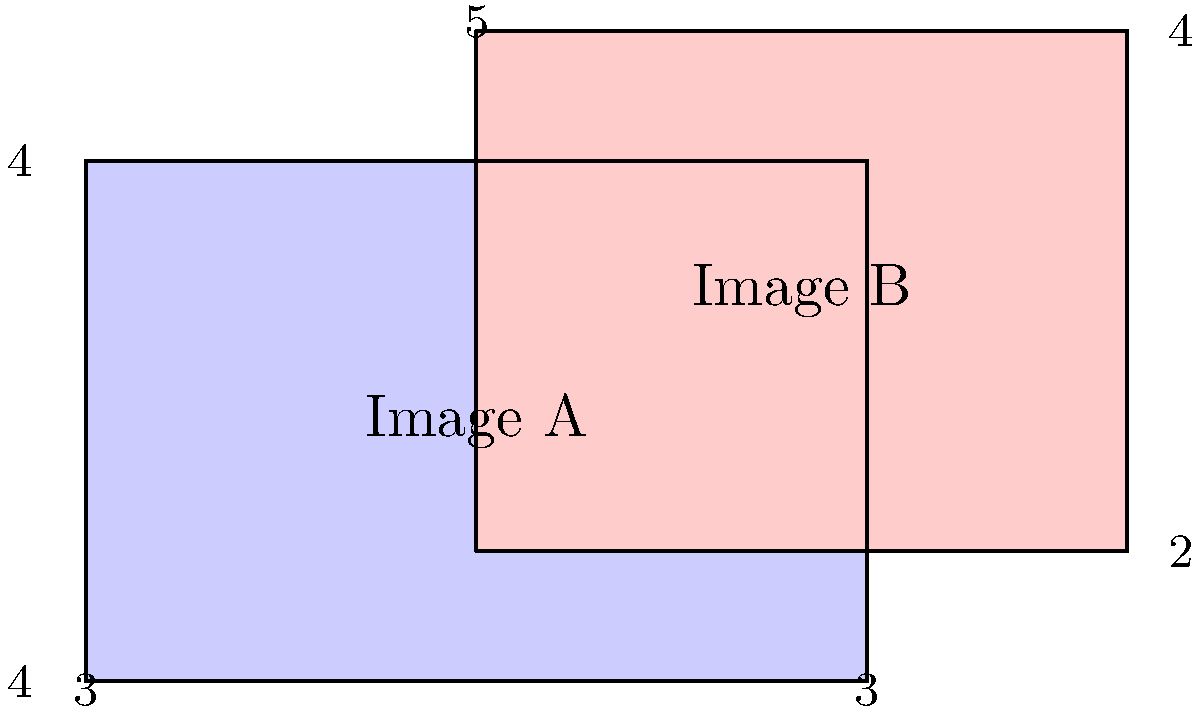You're working on an iOS app that processes PNG images. You need to calculate the difference in area between two overlapping image masks, represented by rectangles A and B in the diagram. The dimensions are given in arbitrary units. What is the difference in area between the non-overlapping regions of these two masks? To solve this problem, we'll follow these steps:

1. Calculate the area of Image A:
   $A_A = 6 * 4 = 24$ square units

2. Calculate the area of Image B:
   $A_B = 5 * 4 = 20$ square units

3. Calculate the area of the overlapping region:
   Width of overlap = $6 - 3 = 3$ units
   Height of overlap = $4 - 1 = 3$ units
   $A_{overlap} = 3 * 3 = 9$ square units

4. Calculate the non-overlapping area of Image A:
   $A_{A_{non-overlap}} = A_A - A_{overlap} = 24 - 9 = 15$ square units

5. Calculate the non-overlapping area of Image B:
   $A_{B_{non-overlap}} = A_B - A_{overlap} = 20 - 9 = 11$ square units

6. Calculate the difference between non-overlapping areas:
   $A_{difference} = |A_{A_{non-overlap}} - A_{B_{non-overlap}}| = |15 - 11| = 4$ square units

Therefore, the difference in area between the non-overlapping regions of these two masks is 4 square units.
Answer: 4 square units 